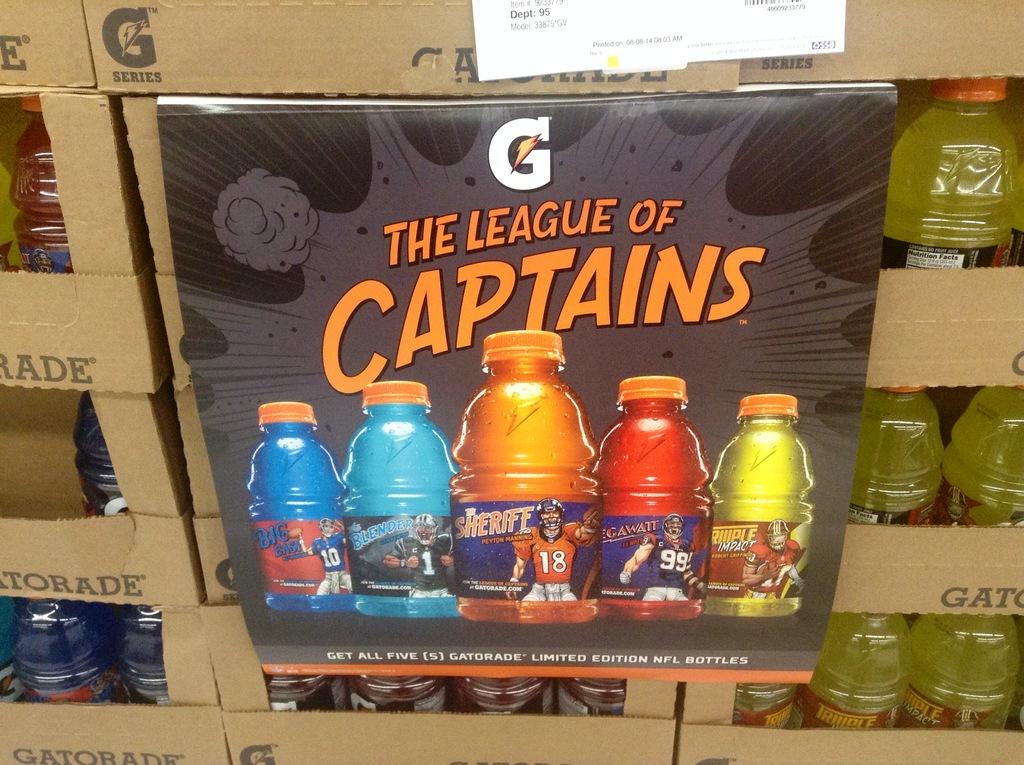What is the name on the gatorade poster?
Keep it short and to the point. The league of captains. What is the number of the player on the bottle in the center?
Provide a short and direct response. 18. 